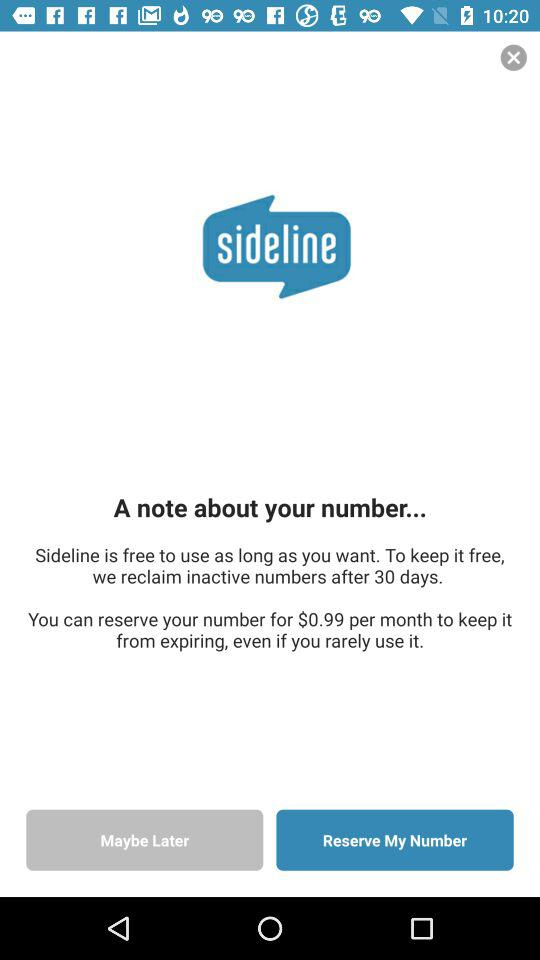How long do I have to use my number before it expires?
Answer the question using a single word or phrase. 30 days 